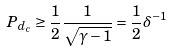Convert formula to latex. <formula><loc_0><loc_0><loc_500><loc_500>P _ { d _ { c } } \geq \frac { 1 } { 2 } \frac { 1 } { \sqrt { \gamma - 1 } } = \frac { 1 } { 2 } \delta ^ { - 1 }</formula> 